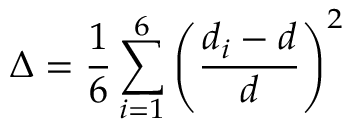<formula> <loc_0><loc_0><loc_500><loc_500>\Delta = \frac { 1 } { 6 } \sum _ { i = 1 } ^ { 6 } \left ( \frac { d _ { i } - d } { d } \right ) ^ { 2 }</formula> 